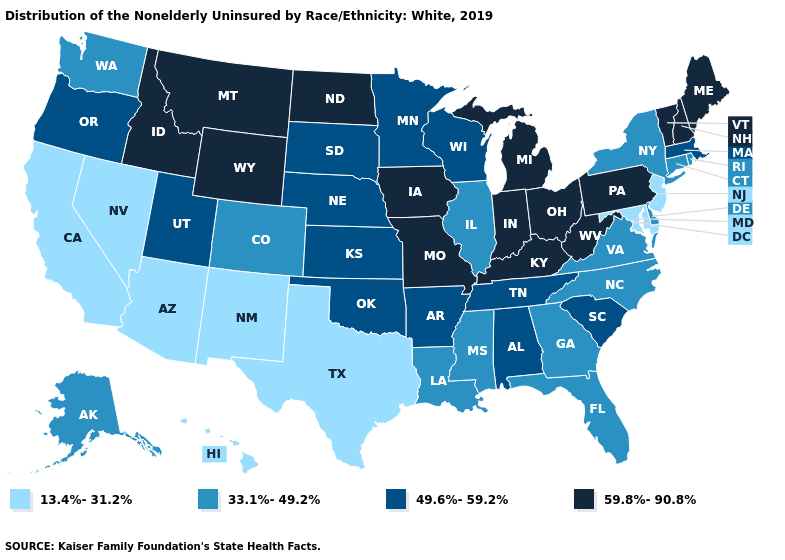Name the states that have a value in the range 59.8%-90.8%?
Answer briefly. Idaho, Indiana, Iowa, Kentucky, Maine, Michigan, Missouri, Montana, New Hampshire, North Dakota, Ohio, Pennsylvania, Vermont, West Virginia, Wyoming. What is the value of Georgia?
Quick response, please. 33.1%-49.2%. Which states hav the highest value in the West?
Give a very brief answer. Idaho, Montana, Wyoming. Does New York have a higher value than New Hampshire?
Be succinct. No. Does New Jersey have a higher value than Ohio?
Quick response, please. No. Does Michigan have a higher value than Kentucky?
Keep it brief. No. What is the lowest value in the South?
Answer briefly. 13.4%-31.2%. What is the lowest value in the MidWest?
Keep it brief. 33.1%-49.2%. How many symbols are there in the legend?
Give a very brief answer. 4. What is the value of Vermont?
Be succinct. 59.8%-90.8%. What is the value of New Jersey?
Short answer required. 13.4%-31.2%. Among the states that border Georgia , which have the lowest value?
Short answer required. Florida, North Carolina. Which states have the lowest value in the South?
Answer briefly. Maryland, Texas. Name the states that have a value in the range 49.6%-59.2%?
Quick response, please. Alabama, Arkansas, Kansas, Massachusetts, Minnesota, Nebraska, Oklahoma, Oregon, South Carolina, South Dakota, Tennessee, Utah, Wisconsin. Name the states that have a value in the range 49.6%-59.2%?
Write a very short answer. Alabama, Arkansas, Kansas, Massachusetts, Minnesota, Nebraska, Oklahoma, Oregon, South Carolina, South Dakota, Tennessee, Utah, Wisconsin. 